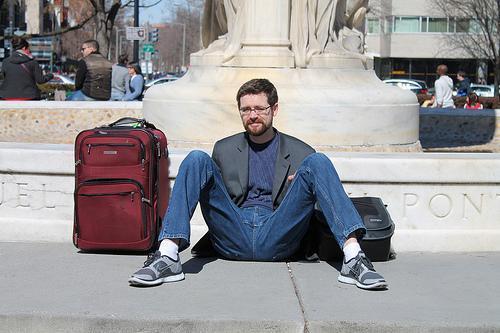How many bags are there?
Give a very brief answer. 2. 